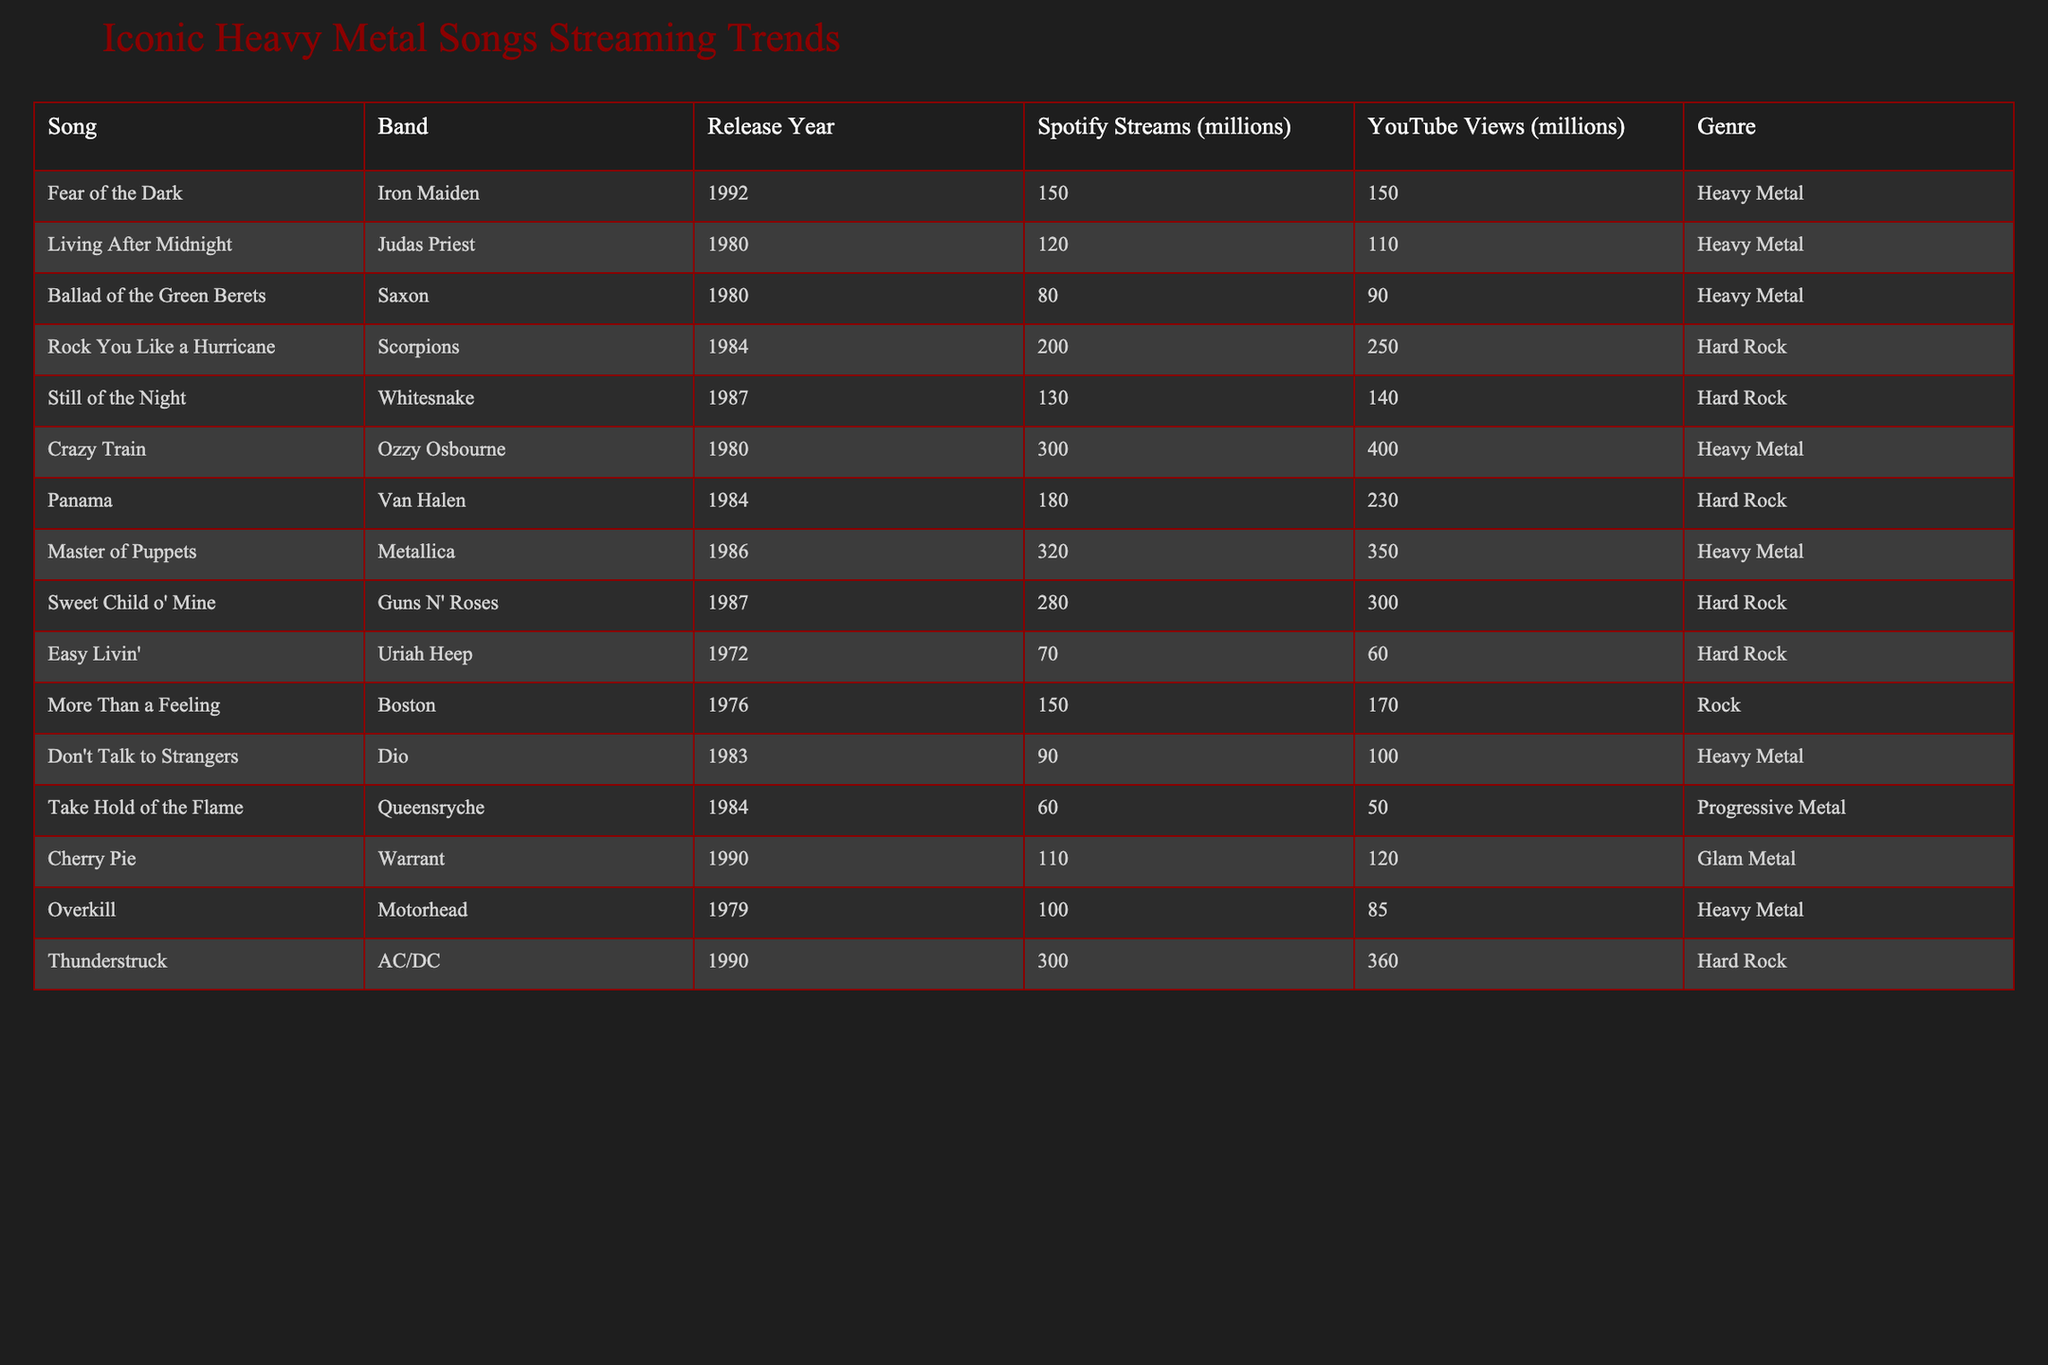What is the song by Iron Maiden in the table? Iron Maiden's song is "Fear of the Dark," as listed in the Band column next to their name.
Answer: "Fear of the Dark" Which song has the highest Spotify streams? "Crazy Train" by Ozzy Osbourne has 300 million streams, which is the highest among the listed songs.
Answer: "Crazy Train" How many millions of YouTube views does "Rock You Like a Hurricane" have? The YouTube views for "Rock You Like a Hurricane" are listed as 250 million in the table.
Answer: 250 million What is the difference in Spotify streams between "Master of Puppets" and "Thunderstruck"? "Master of Puppets" has 320 million streams, and "Thunderstruck" has 300 million streams. The difference is 320 - 300 = 20 million.
Answer: 20 million Is the genre of "Sweet Child o' Mine" Hard Rock? Yes, the genre listed for "Sweet Child o' Mine" in the table is Hard Rock.
Answer: Yes Which band has two songs listed in the table? The bands Iron Maiden, Ozzy Osbourne, and Metallica each have one song listed; however, the bands Scorpions and Whitesnake each have one song as well. None of the bands have two songs in this table.
Answer: No What is the average number of YouTube views for songs in the Heavy Metal genre? The YouTube views for Heavy Metal songs are 150, 110, 90, 360, and 350 million. The total is 150 + 110 + 90 + 350 + 360 = 1060 million, and there are 5 songs, so the average is 1060 / 5 = 212 million.
Answer: 212 million Which song by Dio has the least Spotify streams? "Don't Talk to Strangers" by Dio has 90 million Spotify streams, which is the least for Dio compared to other bands listed.
Answer: 90 million Who has more YouTube views, "Crazy Train" or "Master of Puppets"? "Crazy Train" has 400 million YouTube views, while "Master of Puppets" has 350 million views; since 400 is greater than 350, "Crazy Train" has more views.
Answer: "Crazy Train" Can you find a song from the 80s that falls under the genre of Glam Metal? Yes, "Cherry Pie" by Warrant, released in 1990, fits the Glam Metal genre.
Answer: Yes, "Cherry Pie" 